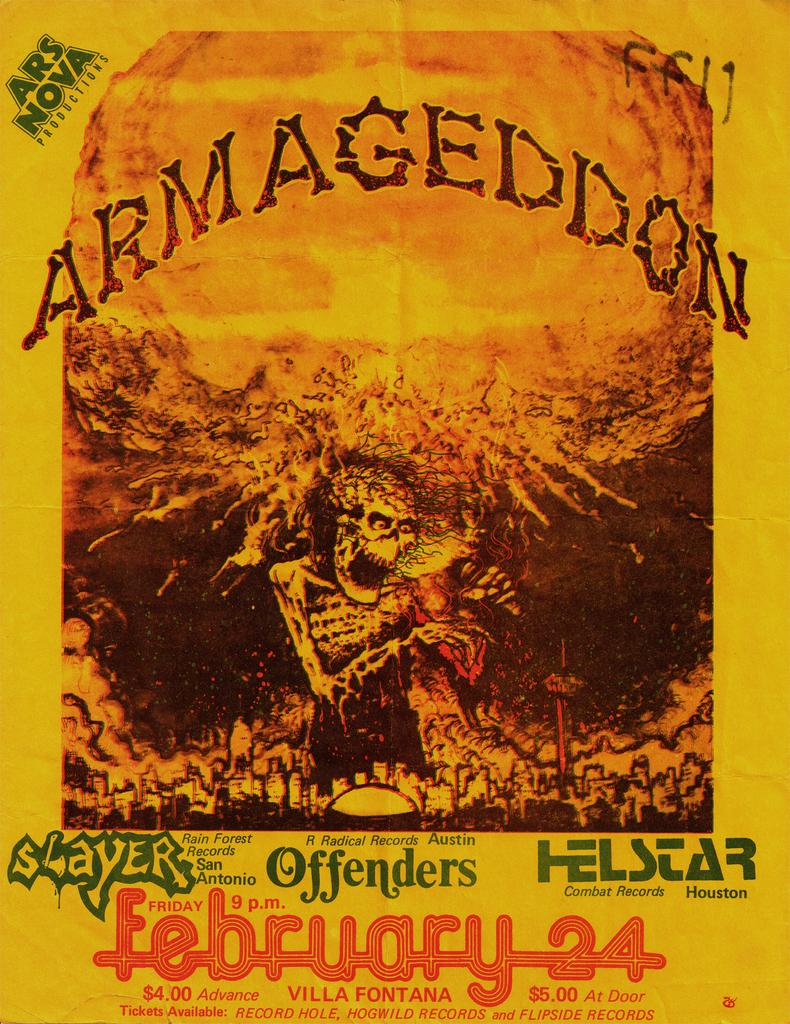<image>
Write a terse but informative summary of the picture. A poster for a music festival called armegeddon features a picture of a large demon looming over a town. 